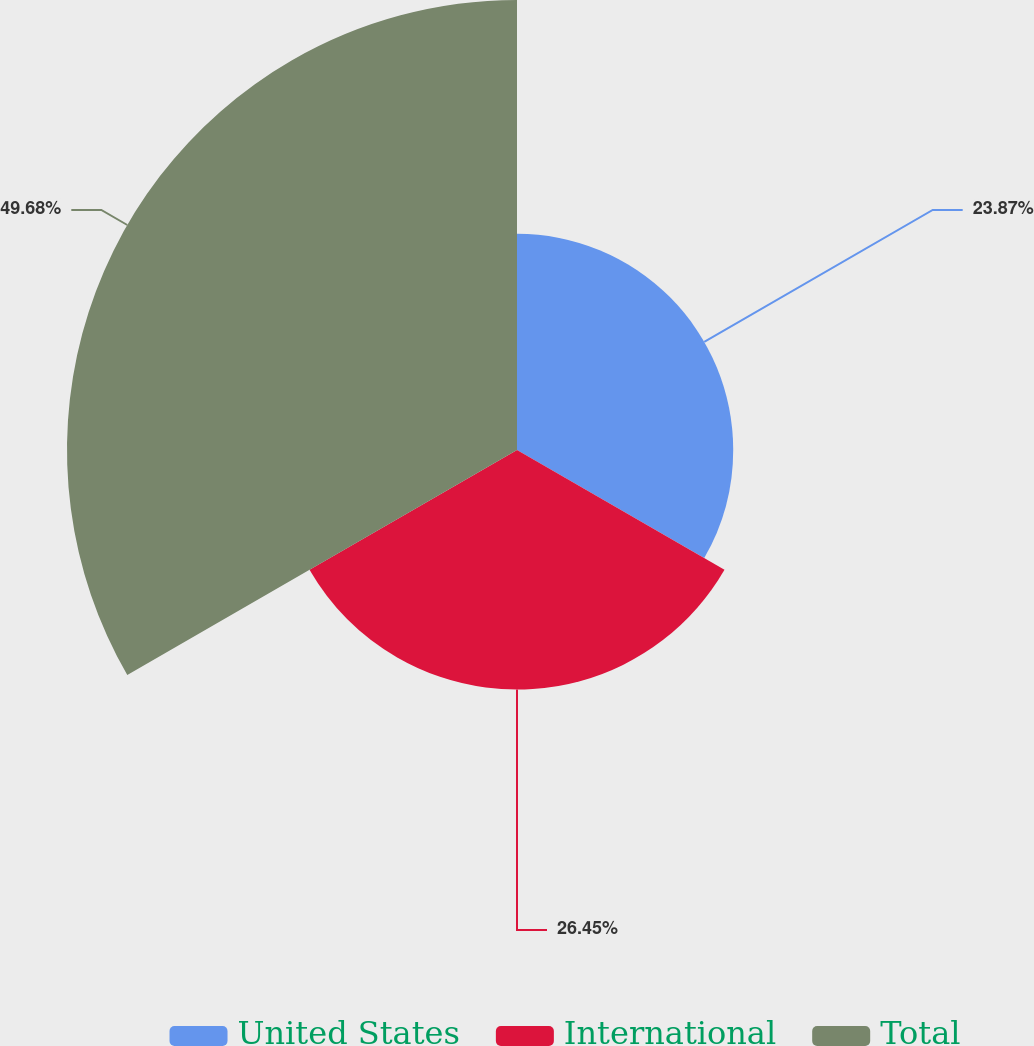<chart> <loc_0><loc_0><loc_500><loc_500><pie_chart><fcel>United States<fcel>International<fcel>Total<nl><fcel>23.87%<fcel>26.45%<fcel>49.68%<nl></chart> 